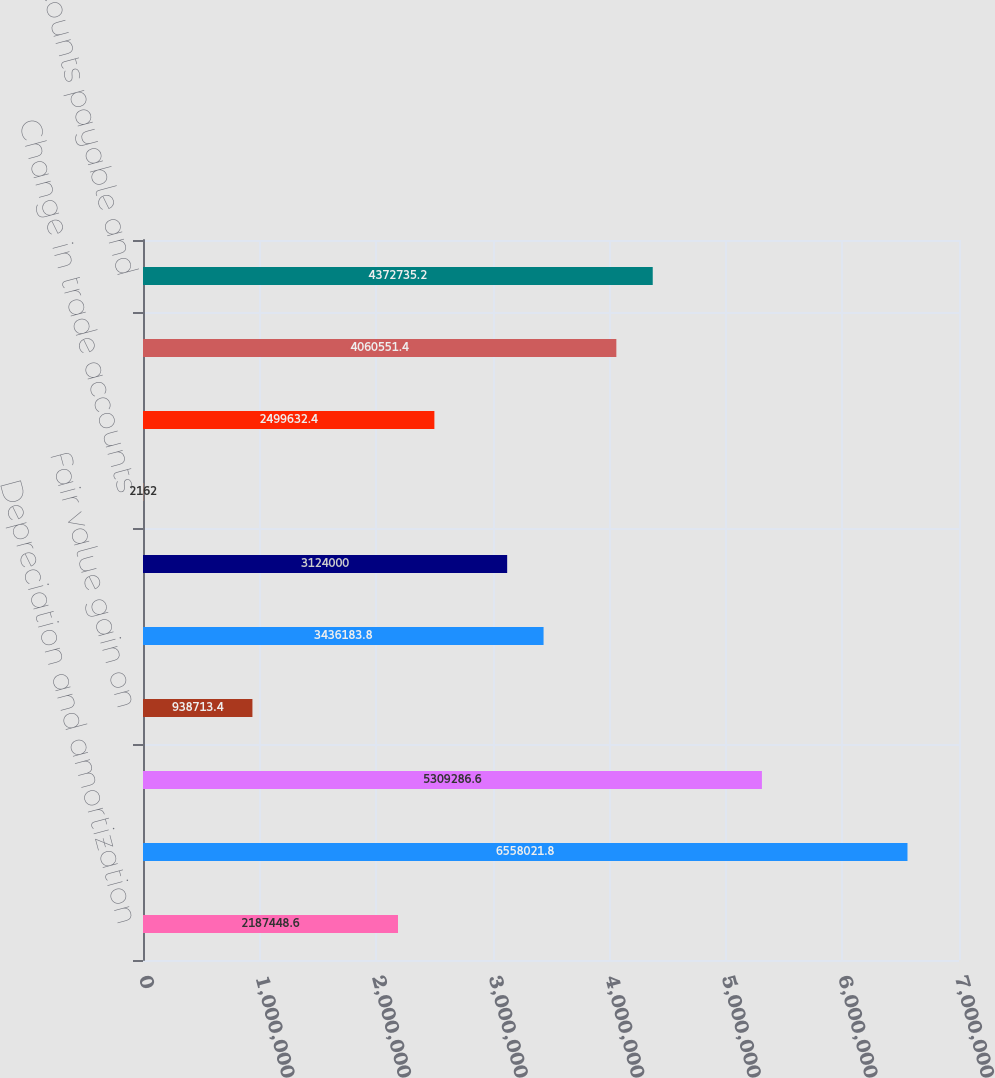Convert chart to OTSL. <chart><loc_0><loc_0><loc_500><loc_500><bar_chart><fcel>Depreciation and amortization<fcel>Provision for doubtful<fcel>Non-cash stock compensation<fcel>Fair value gain on<fcel>Gain on acquisition of<fcel>Loss (gain) on sale of assets<fcel>Change in trade accounts<fcel>Change in merchant settlement<fcel>Change in other assets<fcel>Change in accounts payable and<nl><fcel>2.18745e+06<fcel>6.55802e+06<fcel>5.30929e+06<fcel>938713<fcel>3.43618e+06<fcel>3.124e+06<fcel>2162<fcel>2.49963e+06<fcel>4.06055e+06<fcel>4.37274e+06<nl></chart> 